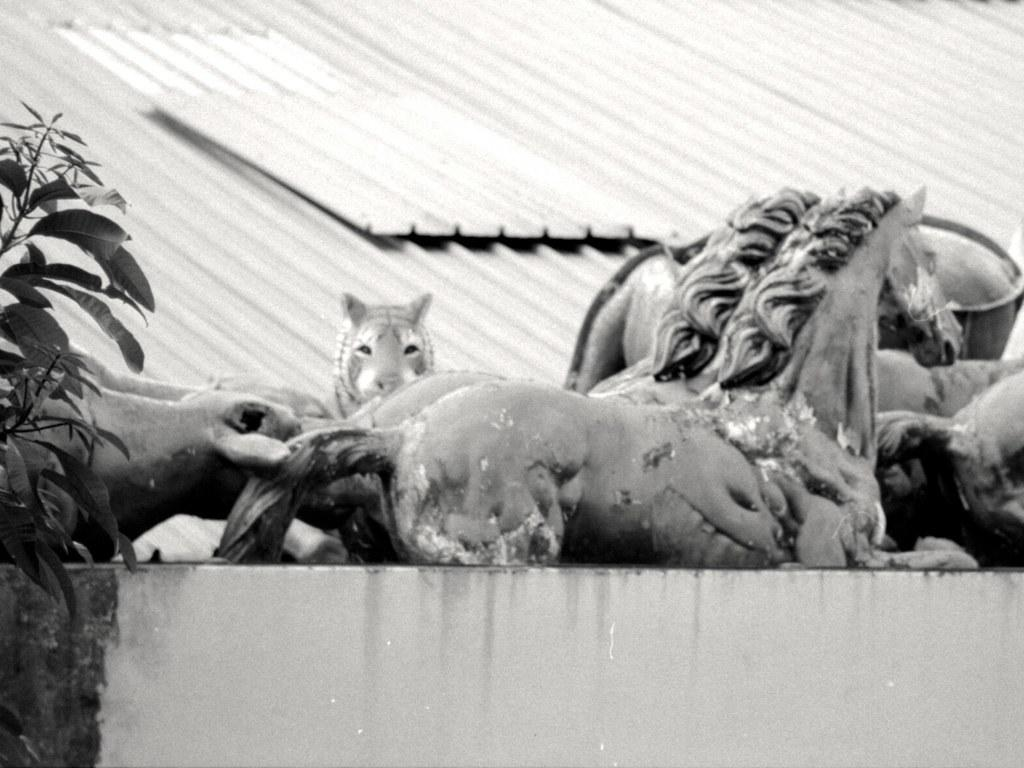What can be seen on the platform in the image? There are statues of animals on a platform in the image. What type of vegetation is visible on the left side of the image? Leaves and stems are visible on the left side of the image. What can be seen in the background of the image? Sheets are present in the background of the image. What type of protest is taking place in the image? There is no protest present in the image; it features statues of animals on a platform, leaves and stems on the left side, and sheets in the background. What is the hope for the park in the image? There is no park mentioned in the image, so it's not possible to determine any hopes for it. 